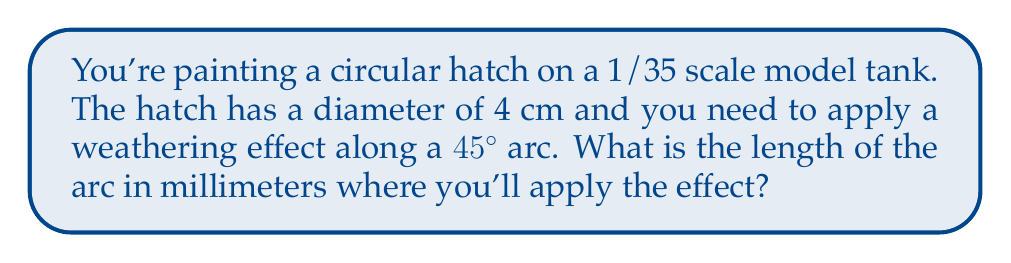Give your solution to this math problem. Let's approach this step-by-step:

1) First, we need to recall the formula for arc length:
   $$ s = r\theta $$
   where $s$ is the arc length, $r$ is the radius, and $\theta$ is the central angle in radians.

2) We're given the diameter of 4 cm, so the radius is half of this:
   $$ r = 2 \text{ cm} $$

3) The angle is given as 45°, but we need to convert this to radians:
   $$ \theta = 45° \times \frac{\pi}{180°} = \frac{\pi}{4} \text{ radians} $$

4) Now we can substitute these values into our arc length formula:
   $$ s = 2 \times \frac{\pi}{4} = \frac{\pi}{2} \text{ cm} $$

5) To convert this to millimeters, we multiply by 10:
   $$ s = \frac{\pi}{2} \times 10 = 5\pi \text{ mm} $$

6) Calculating this:
   $$ s \approx 15.71 \text{ mm} $$

[asy]
unitsize(1cm);
draw(circle((0,0),2));
draw((0,0)--(2,0),Arrow);
draw((0,0)--(1.414,1.414),Arrow);
draw(arc((0,0),2,0,45),linewidth(1.5));
label("45°", (0.8,0.4));
label("r = 2 cm", (1,-0.3));
label("4 cm", (-2.3,0));
[/asy]
Answer: $5\pi \text{ mm}$ (approximately 15.71 mm) 